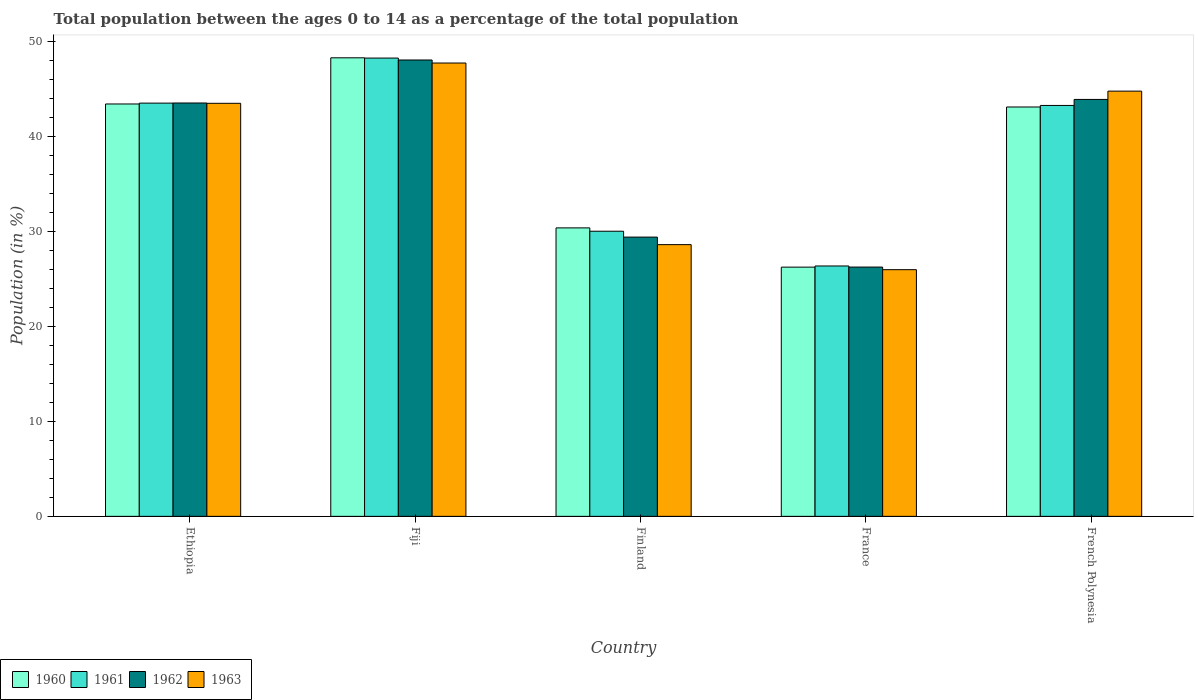How many different coloured bars are there?
Give a very brief answer. 4. What is the label of the 2nd group of bars from the left?
Give a very brief answer. Fiji. What is the percentage of the population ages 0 to 14 in 1961 in Finland?
Offer a terse response. 30.05. Across all countries, what is the maximum percentage of the population ages 0 to 14 in 1963?
Your answer should be compact. 47.78. Across all countries, what is the minimum percentage of the population ages 0 to 14 in 1962?
Your answer should be very brief. 26.27. In which country was the percentage of the population ages 0 to 14 in 1963 maximum?
Provide a succinct answer. Fiji. In which country was the percentage of the population ages 0 to 14 in 1960 minimum?
Offer a very short reply. France. What is the total percentage of the population ages 0 to 14 in 1960 in the graph?
Give a very brief answer. 191.6. What is the difference between the percentage of the population ages 0 to 14 in 1960 in Finland and that in France?
Provide a short and direct response. 4.14. What is the difference between the percentage of the population ages 0 to 14 in 1961 in Fiji and the percentage of the population ages 0 to 14 in 1962 in Finland?
Provide a short and direct response. 18.87. What is the average percentage of the population ages 0 to 14 in 1960 per country?
Provide a succinct answer. 38.32. What is the difference between the percentage of the population ages 0 to 14 of/in 1961 and percentage of the population ages 0 to 14 of/in 1963 in Fiji?
Ensure brevity in your answer.  0.52. What is the ratio of the percentage of the population ages 0 to 14 in 1961 in Fiji to that in France?
Offer a very short reply. 1.83. Is the percentage of the population ages 0 to 14 in 1962 in Ethiopia less than that in Fiji?
Provide a succinct answer. Yes. Is the difference between the percentage of the population ages 0 to 14 in 1961 in Ethiopia and Fiji greater than the difference between the percentage of the population ages 0 to 14 in 1963 in Ethiopia and Fiji?
Keep it short and to the point. No. What is the difference between the highest and the second highest percentage of the population ages 0 to 14 in 1962?
Offer a terse response. 4.53. What is the difference between the highest and the lowest percentage of the population ages 0 to 14 in 1962?
Make the answer very short. 21.82. Is it the case that in every country, the sum of the percentage of the population ages 0 to 14 in 1960 and percentage of the population ages 0 to 14 in 1962 is greater than the percentage of the population ages 0 to 14 in 1963?
Make the answer very short. Yes. How many bars are there?
Offer a very short reply. 20. How many countries are there in the graph?
Make the answer very short. 5. What is the difference between two consecutive major ticks on the Y-axis?
Offer a terse response. 10. Does the graph contain any zero values?
Give a very brief answer. No. Does the graph contain grids?
Provide a short and direct response. No. Where does the legend appear in the graph?
Ensure brevity in your answer.  Bottom left. What is the title of the graph?
Provide a short and direct response. Total population between the ages 0 to 14 as a percentage of the total population. Does "1993" appear as one of the legend labels in the graph?
Keep it short and to the point. No. What is the Population (in %) of 1960 in Ethiopia?
Provide a short and direct response. 43.46. What is the Population (in %) of 1961 in Ethiopia?
Your response must be concise. 43.55. What is the Population (in %) of 1962 in Ethiopia?
Your response must be concise. 43.56. What is the Population (in %) in 1963 in Ethiopia?
Keep it short and to the point. 43.53. What is the Population (in %) in 1960 in Fiji?
Make the answer very short. 48.33. What is the Population (in %) in 1961 in Fiji?
Provide a succinct answer. 48.3. What is the Population (in %) of 1962 in Fiji?
Provide a succinct answer. 48.1. What is the Population (in %) in 1963 in Fiji?
Provide a short and direct response. 47.78. What is the Population (in %) of 1960 in Finland?
Your answer should be compact. 30.4. What is the Population (in %) in 1961 in Finland?
Give a very brief answer. 30.05. What is the Population (in %) in 1962 in Finland?
Give a very brief answer. 29.43. What is the Population (in %) of 1963 in Finland?
Make the answer very short. 28.64. What is the Population (in %) of 1960 in France?
Offer a very short reply. 26.27. What is the Population (in %) in 1961 in France?
Provide a short and direct response. 26.39. What is the Population (in %) of 1962 in France?
Keep it short and to the point. 26.27. What is the Population (in %) of 1963 in France?
Ensure brevity in your answer.  26. What is the Population (in %) in 1960 in French Polynesia?
Offer a very short reply. 43.14. What is the Population (in %) of 1961 in French Polynesia?
Provide a short and direct response. 43.31. What is the Population (in %) in 1962 in French Polynesia?
Keep it short and to the point. 43.94. What is the Population (in %) in 1963 in French Polynesia?
Give a very brief answer. 44.81. Across all countries, what is the maximum Population (in %) of 1960?
Your response must be concise. 48.33. Across all countries, what is the maximum Population (in %) of 1961?
Offer a terse response. 48.3. Across all countries, what is the maximum Population (in %) of 1962?
Keep it short and to the point. 48.1. Across all countries, what is the maximum Population (in %) in 1963?
Your answer should be compact. 47.78. Across all countries, what is the minimum Population (in %) of 1960?
Offer a terse response. 26.27. Across all countries, what is the minimum Population (in %) of 1961?
Offer a very short reply. 26.39. Across all countries, what is the minimum Population (in %) of 1962?
Offer a terse response. 26.27. Across all countries, what is the minimum Population (in %) of 1963?
Provide a short and direct response. 26. What is the total Population (in %) in 1960 in the graph?
Your response must be concise. 191.6. What is the total Population (in %) of 1961 in the graph?
Keep it short and to the point. 191.59. What is the total Population (in %) in 1962 in the graph?
Provide a short and direct response. 191.3. What is the total Population (in %) of 1963 in the graph?
Give a very brief answer. 190.75. What is the difference between the Population (in %) in 1960 in Ethiopia and that in Fiji?
Keep it short and to the point. -4.87. What is the difference between the Population (in %) of 1961 in Ethiopia and that in Fiji?
Offer a terse response. -4.75. What is the difference between the Population (in %) of 1962 in Ethiopia and that in Fiji?
Offer a very short reply. -4.53. What is the difference between the Population (in %) in 1963 in Ethiopia and that in Fiji?
Make the answer very short. -4.25. What is the difference between the Population (in %) in 1960 in Ethiopia and that in Finland?
Provide a short and direct response. 13.06. What is the difference between the Population (in %) of 1961 in Ethiopia and that in Finland?
Offer a terse response. 13.5. What is the difference between the Population (in %) in 1962 in Ethiopia and that in Finland?
Keep it short and to the point. 14.13. What is the difference between the Population (in %) in 1963 in Ethiopia and that in Finland?
Offer a very short reply. 14.9. What is the difference between the Population (in %) of 1960 in Ethiopia and that in France?
Offer a terse response. 17.19. What is the difference between the Population (in %) of 1961 in Ethiopia and that in France?
Provide a short and direct response. 17.16. What is the difference between the Population (in %) in 1962 in Ethiopia and that in France?
Your answer should be compact. 17.29. What is the difference between the Population (in %) in 1963 in Ethiopia and that in France?
Your answer should be very brief. 17.54. What is the difference between the Population (in %) of 1960 in Ethiopia and that in French Polynesia?
Make the answer very short. 0.32. What is the difference between the Population (in %) of 1961 in Ethiopia and that in French Polynesia?
Your answer should be very brief. 0.25. What is the difference between the Population (in %) in 1962 in Ethiopia and that in French Polynesia?
Your answer should be compact. -0.37. What is the difference between the Population (in %) of 1963 in Ethiopia and that in French Polynesia?
Give a very brief answer. -1.28. What is the difference between the Population (in %) of 1960 in Fiji and that in Finland?
Give a very brief answer. 17.92. What is the difference between the Population (in %) in 1961 in Fiji and that in Finland?
Offer a terse response. 18.25. What is the difference between the Population (in %) of 1962 in Fiji and that in Finland?
Your answer should be very brief. 18.66. What is the difference between the Population (in %) in 1963 in Fiji and that in Finland?
Give a very brief answer. 19.14. What is the difference between the Population (in %) of 1960 in Fiji and that in France?
Give a very brief answer. 22.06. What is the difference between the Population (in %) of 1961 in Fiji and that in France?
Make the answer very short. 21.91. What is the difference between the Population (in %) of 1962 in Fiji and that in France?
Ensure brevity in your answer.  21.82. What is the difference between the Population (in %) in 1963 in Fiji and that in France?
Provide a succinct answer. 21.78. What is the difference between the Population (in %) of 1960 in Fiji and that in French Polynesia?
Offer a terse response. 5.18. What is the difference between the Population (in %) of 1961 in Fiji and that in French Polynesia?
Your answer should be very brief. 4.99. What is the difference between the Population (in %) in 1962 in Fiji and that in French Polynesia?
Make the answer very short. 4.16. What is the difference between the Population (in %) of 1963 in Fiji and that in French Polynesia?
Keep it short and to the point. 2.96. What is the difference between the Population (in %) in 1960 in Finland and that in France?
Offer a terse response. 4.14. What is the difference between the Population (in %) of 1961 in Finland and that in France?
Provide a succinct answer. 3.66. What is the difference between the Population (in %) in 1962 in Finland and that in France?
Give a very brief answer. 3.16. What is the difference between the Population (in %) of 1963 in Finland and that in France?
Offer a very short reply. 2.64. What is the difference between the Population (in %) of 1960 in Finland and that in French Polynesia?
Ensure brevity in your answer.  -12.74. What is the difference between the Population (in %) in 1961 in Finland and that in French Polynesia?
Your answer should be very brief. -13.26. What is the difference between the Population (in %) of 1962 in Finland and that in French Polynesia?
Provide a succinct answer. -14.51. What is the difference between the Population (in %) in 1963 in Finland and that in French Polynesia?
Offer a terse response. -16.18. What is the difference between the Population (in %) of 1960 in France and that in French Polynesia?
Offer a terse response. -16.88. What is the difference between the Population (in %) of 1961 in France and that in French Polynesia?
Provide a short and direct response. -16.92. What is the difference between the Population (in %) in 1962 in France and that in French Polynesia?
Your answer should be very brief. -17.67. What is the difference between the Population (in %) in 1963 in France and that in French Polynesia?
Offer a very short reply. -18.82. What is the difference between the Population (in %) of 1960 in Ethiopia and the Population (in %) of 1961 in Fiji?
Your answer should be very brief. -4.84. What is the difference between the Population (in %) of 1960 in Ethiopia and the Population (in %) of 1962 in Fiji?
Give a very brief answer. -4.64. What is the difference between the Population (in %) of 1960 in Ethiopia and the Population (in %) of 1963 in Fiji?
Offer a very short reply. -4.32. What is the difference between the Population (in %) of 1961 in Ethiopia and the Population (in %) of 1962 in Fiji?
Your response must be concise. -4.54. What is the difference between the Population (in %) of 1961 in Ethiopia and the Population (in %) of 1963 in Fiji?
Give a very brief answer. -4.23. What is the difference between the Population (in %) in 1962 in Ethiopia and the Population (in %) in 1963 in Fiji?
Your answer should be very brief. -4.21. What is the difference between the Population (in %) of 1960 in Ethiopia and the Population (in %) of 1961 in Finland?
Keep it short and to the point. 13.41. What is the difference between the Population (in %) of 1960 in Ethiopia and the Population (in %) of 1962 in Finland?
Your answer should be compact. 14.03. What is the difference between the Population (in %) in 1960 in Ethiopia and the Population (in %) in 1963 in Finland?
Your response must be concise. 14.82. What is the difference between the Population (in %) of 1961 in Ethiopia and the Population (in %) of 1962 in Finland?
Keep it short and to the point. 14.12. What is the difference between the Population (in %) in 1961 in Ethiopia and the Population (in %) in 1963 in Finland?
Ensure brevity in your answer.  14.92. What is the difference between the Population (in %) of 1962 in Ethiopia and the Population (in %) of 1963 in Finland?
Offer a terse response. 14.93. What is the difference between the Population (in %) of 1960 in Ethiopia and the Population (in %) of 1961 in France?
Your response must be concise. 17.07. What is the difference between the Population (in %) in 1960 in Ethiopia and the Population (in %) in 1962 in France?
Offer a terse response. 17.19. What is the difference between the Population (in %) of 1960 in Ethiopia and the Population (in %) of 1963 in France?
Ensure brevity in your answer.  17.46. What is the difference between the Population (in %) of 1961 in Ethiopia and the Population (in %) of 1962 in France?
Ensure brevity in your answer.  17.28. What is the difference between the Population (in %) of 1961 in Ethiopia and the Population (in %) of 1963 in France?
Offer a very short reply. 17.56. What is the difference between the Population (in %) in 1962 in Ethiopia and the Population (in %) in 1963 in France?
Make the answer very short. 17.57. What is the difference between the Population (in %) in 1960 in Ethiopia and the Population (in %) in 1961 in French Polynesia?
Offer a terse response. 0.15. What is the difference between the Population (in %) of 1960 in Ethiopia and the Population (in %) of 1962 in French Polynesia?
Ensure brevity in your answer.  -0.48. What is the difference between the Population (in %) of 1960 in Ethiopia and the Population (in %) of 1963 in French Polynesia?
Your response must be concise. -1.35. What is the difference between the Population (in %) of 1961 in Ethiopia and the Population (in %) of 1962 in French Polynesia?
Make the answer very short. -0.39. What is the difference between the Population (in %) of 1961 in Ethiopia and the Population (in %) of 1963 in French Polynesia?
Your answer should be very brief. -1.26. What is the difference between the Population (in %) in 1962 in Ethiopia and the Population (in %) in 1963 in French Polynesia?
Provide a short and direct response. -1.25. What is the difference between the Population (in %) in 1960 in Fiji and the Population (in %) in 1961 in Finland?
Give a very brief answer. 18.28. What is the difference between the Population (in %) of 1960 in Fiji and the Population (in %) of 1962 in Finland?
Offer a very short reply. 18.9. What is the difference between the Population (in %) in 1960 in Fiji and the Population (in %) in 1963 in Finland?
Offer a terse response. 19.69. What is the difference between the Population (in %) in 1961 in Fiji and the Population (in %) in 1962 in Finland?
Make the answer very short. 18.87. What is the difference between the Population (in %) of 1961 in Fiji and the Population (in %) of 1963 in Finland?
Keep it short and to the point. 19.66. What is the difference between the Population (in %) in 1962 in Fiji and the Population (in %) in 1963 in Finland?
Your answer should be very brief. 19.46. What is the difference between the Population (in %) in 1960 in Fiji and the Population (in %) in 1961 in France?
Your answer should be compact. 21.94. What is the difference between the Population (in %) in 1960 in Fiji and the Population (in %) in 1962 in France?
Provide a succinct answer. 22.05. What is the difference between the Population (in %) in 1960 in Fiji and the Population (in %) in 1963 in France?
Ensure brevity in your answer.  22.33. What is the difference between the Population (in %) of 1961 in Fiji and the Population (in %) of 1962 in France?
Your response must be concise. 22.03. What is the difference between the Population (in %) in 1961 in Fiji and the Population (in %) in 1963 in France?
Offer a terse response. 22.3. What is the difference between the Population (in %) of 1962 in Fiji and the Population (in %) of 1963 in France?
Give a very brief answer. 22.1. What is the difference between the Population (in %) of 1960 in Fiji and the Population (in %) of 1961 in French Polynesia?
Provide a succinct answer. 5.02. What is the difference between the Population (in %) in 1960 in Fiji and the Population (in %) in 1962 in French Polynesia?
Provide a short and direct response. 4.39. What is the difference between the Population (in %) of 1960 in Fiji and the Population (in %) of 1963 in French Polynesia?
Provide a short and direct response. 3.51. What is the difference between the Population (in %) in 1961 in Fiji and the Population (in %) in 1962 in French Polynesia?
Offer a terse response. 4.36. What is the difference between the Population (in %) in 1961 in Fiji and the Population (in %) in 1963 in French Polynesia?
Make the answer very short. 3.48. What is the difference between the Population (in %) in 1962 in Fiji and the Population (in %) in 1963 in French Polynesia?
Give a very brief answer. 3.28. What is the difference between the Population (in %) of 1960 in Finland and the Population (in %) of 1961 in France?
Your answer should be compact. 4.01. What is the difference between the Population (in %) of 1960 in Finland and the Population (in %) of 1962 in France?
Your answer should be compact. 4.13. What is the difference between the Population (in %) in 1960 in Finland and the Population (in %) in 1963 in France?
Keep it short and to the point. 4.41. What is the difference between the Population (in %) of 1961 in Finland and the Population (in %) of 1962 in France?
Your answer should be compact. 3.78. What is the difference between the Population (in %) in 1961 in Finland and the Population (in %) in 1963 in France?
Ensure brevity in your answer.  4.05. What is the difference between the Population (in %) in 1962 in Finland and the Population (in %) in 1963 in France?
Provide a short and direct response. 3.43. What is the difference between the Population (in %) of 1960 in Finland and the Population (in %) of 1961 in French Polynesia?
Your response must be concise. -12.9. What is the difference between the Population (in %) in 1960 in Finland and the Population (in %) in 1962 in French Polynesia?
Offer a very short reply. -13.54. What is the difference between the Population (in %) in 1960 in Finland and the Population (in %) in 1963 in French Polynesia?
Provide a short and direct response. -14.41. What is the difference between the Population (in %) of 1961 in Finland and the Population (in %) of 1962 in French Polynesia?
Offer a terse response. -13.89. What is the difference between the Population (in %) in 1961 in Finland and the Population (in %) in 1963 in French Polynesia?
Keep it short and to the point. -14.77. What is the difference between the Population (in %) of 1962 in Finland and the Population (in %) of 1963 in French Polynesia?
Provide a short and direct response. -15.38. What is the difference between the Population (in %) in 1960 in France and the Population (in %) in 1961 in French Polynesia?
Make the answer very short. -17.04. What is the difference between the Population (in %) in 1960 in France and the Population (in %) in 1962 in French Polynesia?
Keep it short and to the point. -17.67. What is the difference between the Population (in %) of 1960 in France and the Population (in %) of 1963 in French Polynesia?
Provide a short and direct response. -18.55. What is the difference between the Population (in %) in 1961 in France and the Population (in %) in 1962 in French Polynesia?
Provide a short and direct response. -17.55. What is the difference between the Population (in %) in 1961 in France and the Population (in %) in 1963 in French Polynesia?
Provide a succinct answer. -18.43. What is the difference between the Population (in %) in 1962 in France and the Population (in %) in 1963 in French Polynesia?
Give a very brief answer. -18.54. What is the average Population (in %) in 1960 per country?
Offer a very short reply. 38.32. What is the average Population (in %) of 1961 per country?
Provide a succinct answer. 38.32. What is the average Population (in %) in 1962 per country?
Your response must be concise. 38.26. What is the average Population (in %) of 1963 per country?
Give a very brief answer. 38.15. What is the difference between the Population (in %) in 1960 and Population (in %) in 1961 in Ethiopia?
Make the answer very short. -0.09. What is the difference between the Population (in %) of 1960 and Population (in %) of 1962 in Ethiopia?
Your answer should be compact. -0.1. What is the difference between the Population (in %) in 1960 and Population (in %) in 1963 in Ethiopia?
Offer a terse response. -0.07. What is the difference between the Population (in %) in 1961 and Population (in %) in 1962 in Ethiopia?
Your response must be concise. -0.01. What is the difference between the Population (in %) in 1962 and Population (in %) in 1963 in Ethiopia?
Keep it short and to the point. 0.03. What is the difference between the Population (in %) in 1960 and Population (in %) in 1961 in Fiji?
Ensure brevity in your answer.  0.03. What is the difference between the Population (in %) of 1960 and Population (in %) of 1962 in Fiji?
Ensure brevity in your answer.  0.23. What is the difference between the Population (in %) of 1960 and Population (in %) of 1963 in Fiji?
Provide a short and direct response. 0.55. What is the difference between the Population (in %) of 1961 and Population (in %) of 1962 in Fiji?
Your response must be concise. 0.2. What is the difference between the Population (in %) in 1961 and Population (in %) in 1963 in Fiji?
Provide a short and direct response. 0.52. What is the difference between the Population (in %) in 1962 and Population (in %) in 1963 in Fiji?
Your answer should be very brief. 0.32. What is the difference between the Population (in %) of 1960 and Population (in %) of 1961 in Finland?
Your answer should be compact. 0.35. What is the difference between the Population (in %) of 1960 and Population (in %) of 1962 in Finland?
Offer a very short reply. 0.97. What is the difference between the Population (in %) in 1960 and Population (in %) in 1963 in Finland?
Offer a very short reply. 1.77. What is the difference between the Population (in %) in 1961 and Population (in %) in 1962 in Finland?
Keep it short and to the point. 0.62. What is the difference between the Population (in %) in 1961 and Population (in %) in 1963 in Finland?
Make the answer very short. 1.41. What is the difference between the Population (in %) of 1962 and Population (in %) of 1963 in Finland?
Provide a short and direct response. 0.79. What is the difference between the Population (in %) in 1960 and Population (in %) in 1961 in France?
Your response must be concise. -0.12. What is the difference between the Population (in %) of 1960 and Population (in %) of 1962 in France?
Make the answer very short. -0.01. What is the difference between the Population (in %) in 1960 and Population (in %) in 1963 in France?
Give a very brief answer. 0.27. What is the difference between the Population (in %) in 1961 and Population (in %) in 1962 in France?
Make the answer very short. 0.12. What is the difference between the Population (in %) in 1961 and Population (in %) in 1963 in France?
Offer a terse response. 0.39. What is the difference between the Population (in %) in 1962 and Population (in %) in 1963 in France?
Ensure brevity in your answer.  0.28. What is the difference between the Population (in %) of 1960 and Population (in %) of 1961 in French Polynesia?
Your response must be concise. -0.16. What is the difference between the Population (in %) of 1960 and Population (in %) of 1962 in French Polynesia?
Offer a terse response. -0.8. What is the difference between the Population (in %) in 1960 and Population (in %) in 1963 in French Polynesia?
Keep it short and to the point. -1.67. What is the difference between the Population (in %) of 1961 and Population (in %) of 1962 in French Polynesia?
Provide a succinct answer. -0.63. What is the difference between the Population (in %) of 1961 and Population (in %) of 1963 in French Polynesia?
Give a very brief answer. -1.51. What is the difference between the Population (in %) in 1962 and Population (in %) in 1963 in French Polynesia?
Your answer should be very brief. -0.87. What is the ratio of the Population (in %) of 1960 in Ethiopia to that in Fiji?
Your answer should be very brief. 0.9. What is the ratio of the Population (in %) of 1961 in Ethiopia to that in Fiji?
Your answer should be compact. 0.9. What is the ratio of the Population (in %) in 1962 in Ethiopia to that in Fiji?
Your answer should be compact. 0.91. What is the ratio of the Population (in %) in 1963 in Ethiopia to that in Fiji?
Offer a very short reply. 0.91. What is the ratio of the Population (in %) in 1960 in Ethiopia to that in Finland?
Your answer should be very brief. 1.43. What is the ratio of the Population (in %) in 1961 in Ethiopia to that in Finland?
Your answer should be compact. 1.45. What is the ratio of the Population (in %) in 1962 in Ethiopia to that in Finland?
Provide a short and direct response. 1.48. What is the ratio of the Population (in %) of 1963 in Ethiopia to that in Finland?
Give a very brief answer. 1.52. What is the ratio of the Population (in %) in 1960 in Ethiopia to that in France?
Provide a short and direct response. 1.65. What is the ratio of the Population (in %) in 1961 in Ethiopia to that in France?
Offer a terse response. 1.65. What is the ratio of the Population (in %) of 1962 in Ethiopia to that in France?
Offer a very short reply. 1.66. What is the ratio of the Population (in %) in 1963 in Ethiopia to that in France?
Keep it short and to the point. 1.67. What is the ratio of the Population (in %) of 1960 in Ethiopia to that in French Polynesia?
Your response must be concise. 1.01. What is the ratio of the Population (in %) in 1961 in Ethiopia to that in French Polynesia?
Your answer should be compact. 1.01. What is the ratio of the Population (in %) in 1963 in Ethiopia to that in French Polynesia?
Provide a short and direct response. 0.97. What is the ratio of the Population (in %) in 1960 in Fiji to that in Finland?
Your answer should be very brief. 1.59. What is the ratio of the Population (in %) in 1961 in Fiji to that in Finland?
Offer a very short reply. 1.61. What is the ratio of the Population (in %) of 1962 in Fiji to that in Finland?
Your answer should be compact. 1.63. What is the ratio of the Population (in %) of 1963 in Fiji to that in Finland?
Make the answer very short. 1.67. What is the ratio of the Population (in %) in 1960 in Fiji to that in France?
Give a very brief answer. 1.84. What is the ratio of the Population (in %) of 1961 in Fiji to that in France?
Give a very brief answer. 1.83. What is the ratio of the Population (in %) in 1962 in Fiji to that in France?
Provide a short and direct response. 1.83. What is the ratio of the Population (in %) of 1963 in Fiji to that in France?
Give a very brief answer. 1.84. What is the ratio of the Population (in %) in 1960 in Fiji to that in French Polynesia?
Ensure brevity in your answer.  1.12. What is the ratio of the Population (in %) of 1961 in Fiji to that in French Polynesia?
Make the answer very short. 1.12. What is the ratio of the Population (in %) in 1962 in Fiji to that in French Polynesia?
Offer a terse response. 1.09. What is the ratio of the Population (in %) in 1963 in Fiji to that in French Polynesia?
Your answer should be compact. 1.07. What is the ratio of the Population (in %) of 1960 in Finland to that in France?
Offer a terse response. 1.16. What is the ratio of the Population (in %) of 1961 in Finland to that in France?
Keep it short and to the point. 1.14. What is the ratio of the Population (in %) of 1962 in Finland to that in France?
Provide a succinct answer. 1.12. What is the ratio of the Population (in %) of 1963 in Finland to that in France?
Offer a terse response. 1.1. What is the ratio of the Population (in %) of 1960 in Finland to that in French Polynesia?
Provide a short and direct response. 0.7. What is the ratio of the Population (in %) in 1961 in Finland to that in French Polynesia?
Make the answer very short. 0.69. What is the ratio of the Population (in %) in 1962 in Finland to that in French Polynesia?
Ensure brevity in your answer.  0.67. What is the ratio of the Population (in %) in 1963 in Finland to that in French Polynesia?
Offer a terse response. 0.64. What is the ratio of the Population (in %) in 1960 in France to that in French Polynesia?
Offer a terse response. 0.61. What is the ratio of the Population (in %) in 1961 in France to that in French Polynesia?
Ensure brevity in your answer.  0.61. What is the ratio of the Population (in %) of 1962 in France to that in French Polynesia?
Your answer should be compact. 0.6. What is the ratio of the Population (in %) in 1963 in France to that in French Polynesia?
Keep it short and to the point. 0.58. What is the difference between the highest and the second highest Population (in %) in 1960?
Offer a very short reply. 4.87. What is the difference between the highest and the second highest Population (in %) of 1961?
Ensure brevity in your answer.  4.75. What is the difference between the highest and the second highest Population (in %) of 1962?
Provide a short and direct response. 4.16. What is the difference between the highest and the second highest Population (in %) in 1963?
Keep it short and to the point. 2.96. What is the difference between the highest and the lowest Population (in %) of 1960?
Provide a succinct answer. 22.06. What is the difference between the highest and the lowest Population (in %) in 1961?
Your answer should be compact. 21.91. What is the difference between the highest and the lowest Population (in %) in 1962?
Provide a short and direct response. 21.82. What is the difference between the highest and the lowest Population (in %) in 1963?
Offer a terse response. 21.78. 